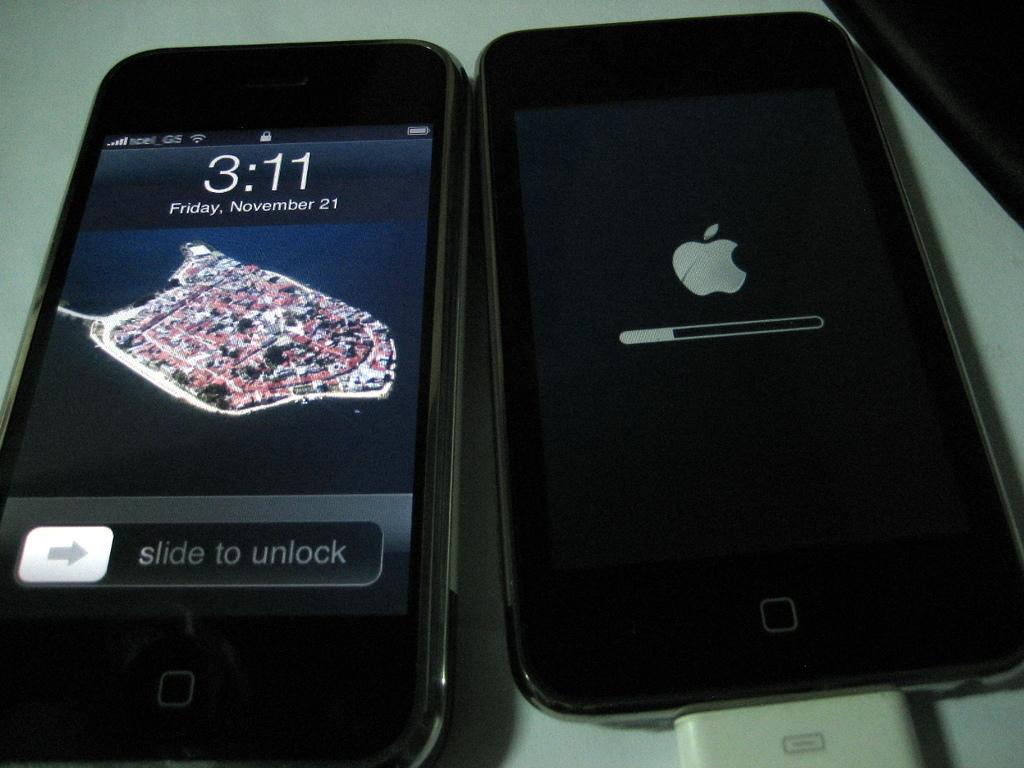<image>
Provide a brief description of the given image. AN APPLE IPHONE SAYING IT IS FRIDAY NOVEMBER 21 